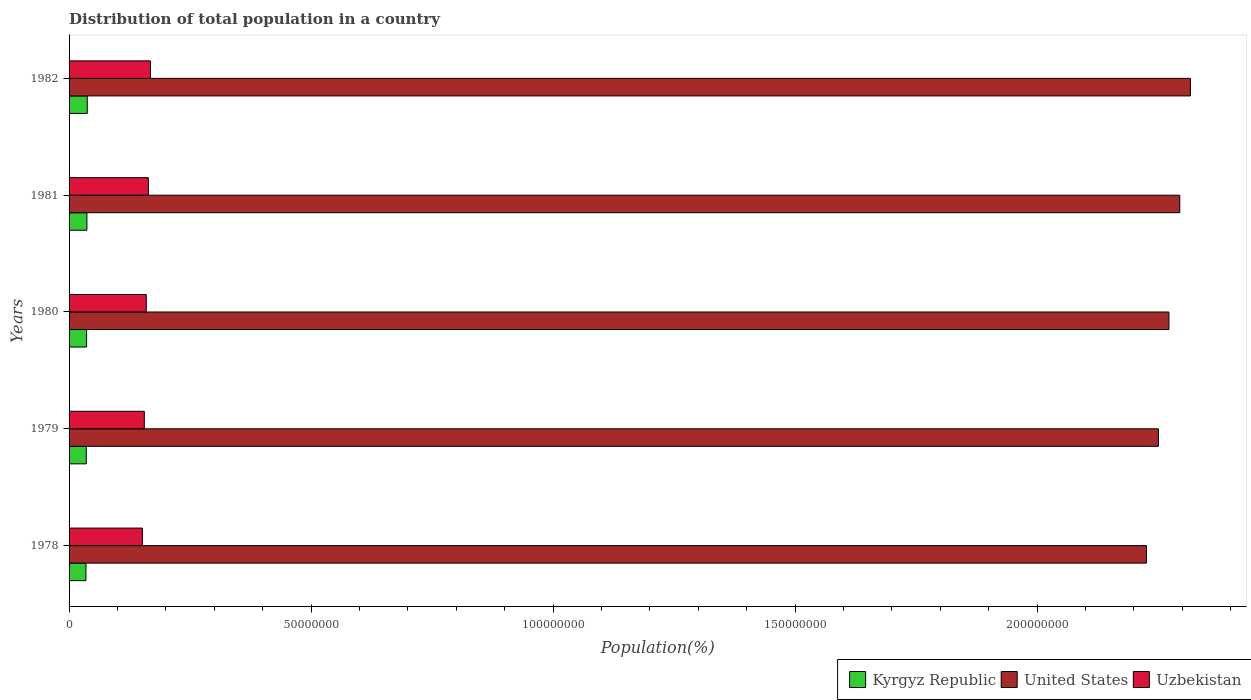Are the number of bars per tick equal to the number of legend labels?
Ensure brevity in your answer.  Yes. Are the number of bars on each tick of the Y-axis equal?
Keep it short and to the point. Yes. How many bars are there on the 5th tick from the bottom?
Your response must be concise. 3. What is the population of in United States in 1978?
Provide a succinct answer. 2.23e+08. Across all years, what is the maximum population of in Uzbekistan?
Your answer should be compact. 1.68e+07. Across all years, what is the minimum population of in Kyrgyz Republic?
Provide a short and direct response. 3.49e+06. In which year was the population of in Kyrgyz Republic maximum?
Your answer should be compact. 1982. In which year was the population of in Uzbekistan minimum?
Provide a succinct answer. 1978. What is the total population of in Uzbekistan in the graph?
Make the answer very short. 7.98e+07. What is the difference between the population of in United States in 1978 and that in 1979?
Offer a very short reply. -2.47e+06. What is the difference between the population of in Kyrgyz Republic in 1980 and the population of in Uzbekistan in 1982?
Keep it short and to the point. -1.32e+07. What is the average population of in Uzbekistan per year?
Your answer should be very brief. 1.60e+07. In the year 1982, what is the difference between the population of in Uzbekistan and population of in Kyrgyz Republic?
Your answer should be very brief. 1.31e+07. What is the ratio of the population of in Kyrgyz Republic in 1980 to that in 1981?
Provide a succinct answer. 0.98. Is the population of in Uzbekistan in 1981 less than that in 1982?
Offer a very short reply. Yes. Is the difference between the population of in Uzbekistan in 1980 and 1981 greater than the difference between the population of in Kyrgyz Republic in 1980 and 1981?
Your answer should be very brief. No. What is the difference between the highest and the second highest population of in Kyrgyz Republic?
Make the answer very short. 7.35e+04. What is the difference between the highest and the lowest population of in Uzbekistan?
Keep it short and to the point. 1.66e+06. Is the sum of the population of in Kyrgyz Republic in 1978 and 1981 greater than the maximum population of in Uzbekistan across all years?
Your answer should be very brief. No. What does the 3rd bar from the top in 1978 represents?
Make the answer very short. Kyrgyz Republic. What does the 2nd bar from the bottom in 1981 represents?
Your answer should be compact. United States. Is it the case that in every year, the sum of the population of in Uzbekistan and population of in Kyrgyz Republic is greater than the population of in United States?
Your answer should be compact. No. Are all the bars in the graph horizontal?
Offer a terse response. Yes. Are the values on the major ticks of X-axis written in scientific E-notation?
Keep it short and to the point. No. Does the graph contain any zero values?
Offer a very short reply. No. What is the title of the graph?
Your answer should be very brief. Distribution of total population in a country. Does "Middle income" appear as one of the legend labels in the graph?
Keep it short and to the point. No. What is the label or title of the X-axis?
Ensure brevity in your answer.  Population(%). What is the Population(%) in Kyrgyz Republic in 1978?
Offer a very short reply. 3.49e+06. What is the Population(%) in United States in 1978?
Your response must be concise. 2.23e+08. What is the Population(%) of Uzbekistan in 1978?
Ensure brevity in your answer.  1.51e+07. What is the Population(%) of Kyrgyz Republic in 1979?
Keep it short and to the point. 3.55e+06. What is the Population(%) in United States in 1979?
Offer a terse response. 2.25e+08. What is the Population(%) of Uzbekistan in 1979?
Your answer should be compact. 1.55e+07. What is the Population(%) of Kyrgyz Republic in 1980?
Your response must be concise. 3.62e+06. What is the Population(%) in United States in 1980?
Keep it short and to the point. 2.27e+08. What is the Population(%) of Uzbekistan in 1980?
Provide a short and direct response. 1.60e+07. What is the Population(%) of Kyrgyz Republic in 1981?
Your answer should be very brief. 3.69e+06. What is the Population(%) of United States in 1981?
Keep it short and to the point. 2.29e+08. What is the Population(%) in Uzbekistan in 1981?
Keep it short and to the point. 1.64e+07. What is the Population(%) in Kyrgyz Republic in 1982?
Provide a short and direct response. 3.76e+06. What is the Population(%) of United States in 1982?
Your response must be concise. 2.32e+08. What is the Population(%) in Uzbekistan in 1982?
Your response must be concise. 1.68e+07. Across all years, what is the maximum Population(%) in Kyrgyz Republic?
Provide a succinct answer. 3.76e+06. Across all years, what is the maximum Population(%) of United States?
Offer a very short reply. 2.32e+08. Across all years, what is the maximum Population(%) of Uzbekistan?
Ensure brevity in your answer.  1.68e+07. Across all years, what is the minimum Population(%) of Kyrgyz Republic?
Give a very brief answer. 3.49e+06. Across all years, what is the minimum Population(%) in United States?
Make the answer very short. 2.23e+08. Across all years, what is the minimum Population(%) of Uzbekistan?
Your response must be concise. 1.51e+07. What is the total Population(%) of Kyrgyz Republic in the graph?
Make the answer very short. 1.81e+07. What is the total Population(%) of United States in the graph?
Provide a short and direct response. 1.14e+09. What is the total Population(%) in Uzbekistan in the graph?
Your response must be concise. 7.98e+07. What is the difference between the Population(%) of Kyrgyz Republic in 1978 and that in 1979?
Offer a very short reply. -6.49e+04. What is the difference between the Population(%) in United States in 1978 and that in 1979?
Your response must be concise. -2.47e+06. What is the difference between the Population(%) in Uzbekistan in 1978 and that in 1979?
Give a very brief answer. -3.95e+05. What is the difference between the Population(%) in Kyrgyz Republic in 1978 and that in 1980?
Your response must be concise. -1.30e+05. What is the difference between the Population(%) in United States in 1978 and that in 1980?
Offer a very short reply. -4.64e+06. What is the difference between the Population(%) of Uzbekistan in 1978 and that in 1980?
Ensure brevity in your answer.  -8.03e+05. What is the difference between the Population(%) in Kyrgyz Republic in 1978 and that in 1981?
Offer a terse response. -1.99e+05. What is the difference between the Population(%) of United States in 1978 and that in 1981?
Your answer should be very brief. -6.88e+06. What is the difference between the Population(%) of Uzbekistan in 1978 and that in 1981?
Provide a succinct answer. -1.23e+06. What is the difference between the Population(%) of Kyrgyz Republic in 1978 and that in 1982?
Ensure brevity in your answer.  -2.72e+05. What is the difference between the Population(%) of United States in 1978 and that in 1982?
Give a very brief answer. -9.08e+06. What is the difference between the Population(%) of Uzbekistan in 1978 and that in 1982?
Ensure brevity in your answer.  -1.66e+06. What is the difference between the Population(%) in Kyrgyz Republic in 1979 and that in 1980?
Your response must be concise. -6.54e+04. What is the difference between the Population(%) of United States in 1979 and that in 1980?
Keep it short and to the point. -2.17e+06. What is the difference between the Population(%) in Uzbekistan in 1979 and that in 1980?
Keep it short and to the point. -4.08e+05. What is the difference between the Population(%) of Kyrgyz Republic in 1979 and that in 1981?
Make the answer very short. -1.34e+05. What is the difference between the Population(%) in United States in 1979 and that in 1981?
Ensure brevity in your answer.  -4.41e+06. What is the difference between the Population(%) of Uzbekistan in 1979 and that in 1981?
Keep it short and to the point. -8.32e+05. What is the difference between the Population(%) of Kyrgyz Republic in 1979 and that in 1982?
Provide a succinct answer. -2.07e+05. What is the difference between the Population(%) of United States in 1979 and that in 1982?
Offer a terse response. -6.61e+06. What is the difference between the Population(%) in Uzbekistan in 1979 and that in 1982?
Offer a very short reply. -1.27e+06. What is the difference between the Population(%) of Kyrgyz Republic in 1980 and that in 1981?
Provide a succinct answer. -6.84e+04. What is the difference between the Population(%) of United States in 1980 and that in 1981?
Provide a short and direct response. -2.24e+06. What is the difference between the Population(%) in Uzbekistan in 1980 and that in 1981?
Give a very brief answer. -4.23e+05. What is the difference between the Population(%) of Kyrgyz Republic in 1980 and that in 1982?
Provide a succinct answer. -1.42e+05. What is the difference between the Population(%) of United States in 1980 and that in 1982?
Offer a terse response. -4.44e+06. What is the difference between the Population(%) of Uzbekistan in 1980 and that in 1982?
Make the answer very short. -8.59e+05. What is the difference between the Population(%) in Kyrgyz Republic in 1981 and that in 1982?
Your answer should be very brief. -7.35e+04. What is the difference between the Population(%) in United States in 1981 and that in 1982?
Your answer should be compact. -2.20e+06. What is the difference between the Population(%) of Uzbekistan in 1981 and that in 1982?
Give a very brief answer. -4.36e+05. What is the difference between the Population(%) in Kyrgyz Republic in 1978 and the Population(%) in United States in 1979?
Keep it short and to the point. -2.22e+08. What is the difference between the Population(%) of Kyrgyz Republic in 1978 and the Population(%) of Uzbekistan in 1979?
Ensure brevity in your answer.  -1.21e+07. What is the difference between the Population(%) of United States in 1978 and the Population(%) of Uzbekistan in 1979?
Your answer should be very brief. 2.07e+08. What is the difference between the Population(%) in Kyrgyz Republic in 1978 and the Population(%) in United States in 1980?
Your answer should be very brief. -2.24e+08. What is the difference between the Population(%) of Kyrgyz Republic in 1978 and the Population(%) of Uzbekistan in 1980?
Ensure brevity in your answer.  -1.25e+07. What is the difference between the Population(%) of United States in 1978 and the Population(%) of Uzbekistan in 1980?
Your answer should be compact. 2.07e+08. What is the difference between the Population(%) in Kyrgyz Republic in 1978 and the Population(%) in United States in 1981?
Your answer should be very brief. -2.26e+08. What is the difference between the Population(%) in Kyrgyz Republic in 1978 and the Population(%) in Uzbekistan in 1981?
Provide a short and direct response. -1.29e+07. What is the difference between the Population(%) in United States in 1978 and the Population(%) in Uzbekistan in 1981?
Your answer should be very brief. 2.06e+08. What is the difference between the Population(%) of Kyrgyz Republic in 1978 and the Population(%) of United States in 1982?
Provide a succinct answer. -2.28e+08. What is the difference between the Population(%) in Kyrgyz Republic in 1978 and the Population(%) in Uzbekistan in 1982?
Ensure brevity in your answer.  -1.33e+07. What is the difference between the Population(%) in United States in 1978 and the Population(%) in Uzbekistan in 1982?
Your answer should be compact. 2.06e+08. What is the difference between the Population(%) of Kyrgyz Republic in 1979 and the Population(%) of United States in 1980?
Provide a short and direct response. -2.24e+08. What is the difference between the Population(%) of Kyrgyz Republic in 1979 and the Population(%) of Uzbekistan in 1980?
Keep it short and to the point. -1.24e+07. What is the difference between the Population(%) of United States in 1979 and the Population(%) of Uzbekistan in 1980?
Provide a succinct answer. 2.09e+08. What is the difference between the Population(%) in Kyrgyz Republic in 1979 and the Population(%) in United States in 1981?
Offer a very short reply. -2.26e+08. What is the difference between the Population(%) in Kyrgyz Republic in 1979 and the Population(%) in Uzbekistan in 1981?
Give a very brief answer. -1.28e+07. What is the difference between the Population(%) of United States in 1979 and the Population(%) of Uzbekistan in 1981?
Your response must be concise. 2.09e+08. What is the difference between the Population(%) in Kyrgyz Republic in 1979 and the Population(%) in United States in 1982?
Ensure brevity in your answer.  -2.28e+08. What is the difference between the Population(%) of Kyrgyz Republic in 1979 and the Population(%) of Uzbekistan in 1982?
Your answer should be compact. -1.33e+07. What is the difference between the Population(%) in United States in 1979 and the Population(%) in Uzbekistan in 1982?
Your answer should be compact. 2.08e+08. What is the difference between the Population(%) of Kyrgyz Republic in 1980 and the Population(%) of United States in 1981?
Provide a short and direct response. -2.26e+08. What is the difference between the Population(%) in Kyrgyz Republic in 1980 and the Population(%) in Uzbekistan in 1981?
Your answer should be compact. -1.28e+07. What is the difference between the Population(%) in United States in 1980 and the Population(%) in Uzbekistan in 1981?
Your answer should be compact. 2.11e+08. What is the difference between the Population(%) of Kyrgyz Republic in 1980 and the Population(%) of United States in 1982?
Ensure brevity in your answer.  -2.28e+08. What is the difference between the Population(%) of Kyrgyz Republic in 1980 and the Population(%) of Uzbekistan in 1982?
Offer a terse response. -1.32e+07. What is the difference between the Population(%) in United States in 1980 and the Population(%) in Uzbekistan in 1982?
Your answer should be very brief. 2.10e+08. What is the difference between the Population(%) in Kyrgyz Republic in 1981 and the Population(%) in United States in 1982?
Give a very brief answer. -2.28e+08. What is the difference between the Population(%) of Kyrgyz Republic in 1981 and the Population(%) of Uzbekistan in 1982?
Offer a very short reply. -1.31e+07. What is the difference between the Population(%) in United States in 1981 and the Population(%) in Uzbekistan in 1982?
Give a very brief answer. 2.13e+08. What is the average Population(%) in Kyrgyz Republic per year?
Keep it short and to the point. 3.62e+06. What is the average Population(%) in United States per year?
Your response must be concise. 2.27e+08. What is the average Population(%) of Uzbekistan per year?
Keep it short and to the point. 1.60e+07. In the year 1978, what is the difference between the Population(%) of Kyrgyz Republic and Population(%) of United States?
Give a very brief answer. -2.19e+08. In the year 1978, what is the difference between the Population(%) in Kyrgyz Republic and Population(%) in Uzbekistan?
Ensure brevity in your answer.  -1.17e+07. In the year 1978, what is the difference between the Population(%) in United States and Population(%) in Uzbekistan?
Your answer should be compact. 2.07e+08. In the year 1979, what is the difference between the Population(%) of Kyrgyz Republic and Population(%) of United States?
Keep it short and to the point. -2.22e+08. In the year 1979, what is the difference between the Population(%) in Kyrgyz Republic and Population(%) in Uzbekistan?
Your answer should be compact. -1.20e+07. In the year 1979, what is the difference between the Population(%) of United States and Population(%) of Uzbekistan?
Give a very brief answer. 2.10e+08. In the year 1980, what is the difference between the Population(%) of Kyrgyz Republic and Population(%) of United States?
Provide a succinct answer. -2.24e+08. In the year 1980, what is the difference between the Population(%) of Kyrgyz Republic and Population(%) of Uzbekistan?
Offer a very short reply. -1.23e+07. In the year 1980, what is the difference between the Population(%) of United States and Population(%) of Uzbekistan?
Make the answer very short. 2.11e+08. In the year 1981, what is the difference between the Population(%) in Kyrgyz Republic and Population(%) in United States?
Make the answer very short. -2.26e+08. In the year 1981, what is the difference between the Population(%) of Kyrgyz Republic and Population(%) of Uzbekistan?
Provide a succinct answer. -1.27e+07. In the year 1981, what is the difference between the Population(%) of United States and Population(%) of Uzbekistan?
Offer a very short reply. 2.13e+08. In the year 1982, what is the difference between the Population(%) in Kyrgyz Republic and Population(%) in United States?
Keep it short and to the point. -2.28e+08. In the year 1982, what is the difference between the Population(%) of Kyrgyz Republic and Population(%) of Uzbekistan?
Offer a very short reply. -1.31e+07. In the year 1982, what is the difference between the Population(%) of United States and Population(%) of Uzbekistan?
Keep it short and to the point. 2.15e+08. What is the ratio of the Population(%) of Kyrgyz Republic in 1978 to that in 1979?
Provide a succinct answer. 0.98. What is the ratio of the Population(%) of United States in 1978 to that in 1979?
Make the answer very short. 0.99. What is the ratio of the Population(%) in Uzbekistan in 1978 to that in 1979?
Ensure brevity in your answer.  0.97. What is the ratio of the Population(%) in United States in 1978 to that in 1980?
Ensure brevity in your answer.  0.98. What is the ratio of the Population(%) in Uzbekistan in 1978 to that in 1980?
Offer a very short reply. 0.95. What is the ratio of the Population(%) of Kyrgyz Republic in 1978 to that in 1981?
Make the answer very short. 0.95. What is the ratio of the Population(%) in Uzbekistan in 1978 to that in 1981?
Provide a succinct answer. 0.93. What is the ratio of the Population(%) of Kyrgyz Republic in 1978 to that in 1982?
Your response must be concise. 0.93. What is the ratio of the Population(%) in United States in 1978 to that in 1982?
Offer a terse response. 0.96. What is the ratio of the Population(%) of Uzbekistan in 1978 to that in 1982?
Keep it short and to the point. 0.9. What is the ratio of the Population(%) of Kyrgyz Republic in 1979 to that in 1980?
Offer a terse response. 0.98. What is the ratio of the Population(%) of United States in 1979 to that in 1980?
Your response must be concise. 0.99. What is the ratio of the Population(%) in Uzbekistan in 1979 to that in 1980?
Your answer should be compact. 0.97. What is the ratio of the Population(%) in Kyrgyz Republic in 1979 to that in 1981?
Offer a terse response. 0.96. What is the ratio of the Population(%) of United States in 1979 to that in 1981?
Ensure brevity in your answer.  0.98. What is the ratio of the Population(%) of Uzbekistan in 1979 to that in 1981?
Give a very brief answer. 0.95. What is the ratio of the Population(%) of Kyrgyz Republic in 1979 to that in 1982?
Keep it short and to the point. 0.94. What is the ratio of the Population(%) in United States in 1979 to that in 1982?
Your answer should be very brief. 0.97. What is the ratio of the Population(%) in Uzbekistan in 1979 to that in 1982?
Your answer should be very brief. 0.92. What is the ratio of the Population(%) in Kyrgyz Republic in 1980 to that in 1981?
Keep it short and to the point. 0.98. What is the ratio of the Population(%) in United States in 1980 to that in 1981?
Provide a succinct answer. 0.99. What is the ratio of the Population(%) of Uzbekistan in 1980 to that in 1981?
Make the answer very short. 0.97. What is the ratio of the Population(%) in Kyrgyz Republic in 1980 to that in 1982?
Make the answer very short. 0.96. What is the ratio of the Population(%) in United States in 1980 to that in 1982?
Your answer should be compact. 0.98. What is the ratio of the Population(%) of Uzbekistan in 1980 to that in 1982?
Keep it short and to the point. 0.95. What is the ratio of the Population(%) in Kyrgyz Republic in 1981 to that in 1982?
Provide a short and direct response. 0.98. What is the ratio of the Population(%) of United States in 1981 to that in 1982?
Your answer should be compact. 0.99. What is the ratio of the Population(%) of Uzbekistan in 1981 to that in 1982?
Your answer should be very brief. 0.97. What is the difference between the highest and the second highest Population(%) in Kyrgyz Republic?
Make the answer very short. 7.35e+04. What is the difference between the highest and the second highest Population(%) of United States?
Your response must be concise. 2.20e+06. What is the difference between the highest and the second highest Population(%) in Uzbekistan?
Offer a very short reply. 4.36e+05. What is the difference between the highest and the lowest Population(%) in Kyrgyz Republic?
Make the answer very short. 2.72e+05. What is the difference between the highest and the lowest Population(%) of United States?
Offer a very short reply. 9.08e+06. What is the difference between the highest and the lowest Population(%) of Uzbekistan?
Give a very brief answer. 1.66e+06. 